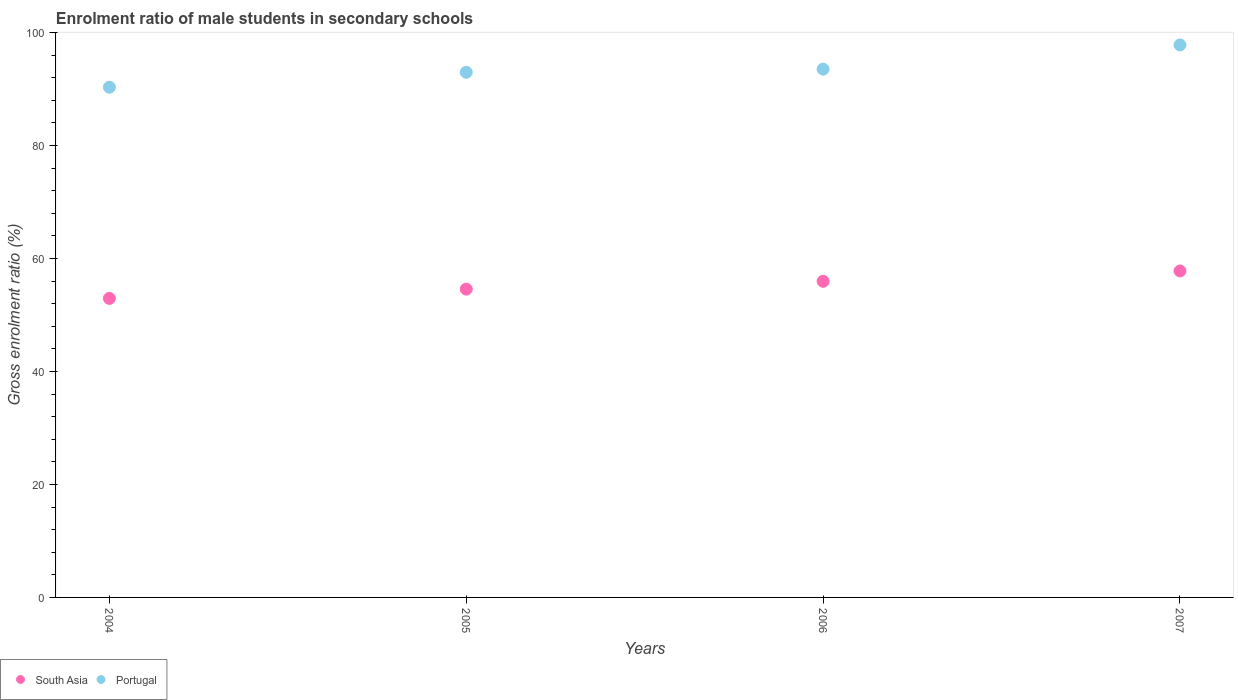Is the number of dotlines equal to the number of legend labels?
Your answer should be compact. Yes. What is the enrolment ratio of male students in secondary schools in South Asia in 2006?
Provide a succinct answer. 55.97. Across all years, what is the maximum enrolment ratio of male students in secondary schools in South Asia?
Give a very brief answer. 57.8. Across all years, what is the minimum enrolment ratio of male students in secondary schools in Portugal?
Offer a very short reply. 90.32. In which year was the enrolment ratio of male students in secondary schools in Portugal maximum?
Ensure brevity in your answer.  2007. In which year was the enrolment ratio of male students in secondary schools in Portugal minimum?
Provide a succinct answer. 2004. What is the total enrolment ratio of male students in secondary schools in Portugal in the graph?
Provide a succinct answer. 374.64. What is the difference between the enrolment ratio of male students in secondary schools in Portugal in 2005 and that in 2007?
Offer a terse response. -4.84. What is the difference between the enrolment ratio of male students in secondary schools in Portugal in 2006 and the enrolment ratio of male students in secondary schools in South Asia in 2004?
Ensure brevity in your answer.  40.59. What is the average enrolment ratio of male students in secondary schools in Portugal per year?
Ensure brevity in your answer.  93.66. In the year 2006, what is the difference between the enrolment ratio of male students in secondary schools in South Asia and enrolment ratio of male students in secondary schools in Portugal?
Keep it short and to the point. -37.55. In how many years, is the enrolment ratio of male students in secondary schools in Portugal greater than 4 %?
Ensure brevity in your answer.  4. What is the ratio of the enrolment ratio of male students in secondary schools in Portugal in 2005 to that in 2006?
Provide a short and direct response. 0.99. Is the enrolment ratio of male students in secondary schools in Portugal in 2005 less than that in 2007?
Your response must be concise. Yes. What is the difference between the highest and the second highest enrolment ratio of male students in secondary schools in South Asia?
Provide a short and direct response. 1.83. What is the difference between the highest and the lowest enrolment ratio of male students in secondary schools in Portugal?
Give a very brief answer. 7.49. In how many years, is the enrolment ratio of male students in secondary schools in Portugal greater than the average enrolment ratio of male students in secondary schools in Portugal taken over all years?
Keep it short and to the point. 1. Does the enrolment ratio of male students in secondary schools in South Asia monotonically increase over the years?
Provide a short and direct response. Yes. Is the enrolment ratio of male students in secondary schools in South Asia strictly less than the enrolment ratio of male students in secondary schools in Portugal over the years?
Offer a terse response. Yes. How many dotlines are there?
Offer a terse response. 2. What is the difference between two consecutive major ticks on the Y-axis?
Ensure brevity in your answer.  20. Are the values on the major ticks of Y-axis written in scientific E-notation?
Provide a short and direct response. No. Does the graph contain any zero values?
Provide a short and direct response. No. Where does the legend appear in the graph?
Your answer should be compact. Bottom left. How many legend labels are there?
Ensure brevity in your answer.  2. How are the legend labels stacked?
Your response must be concise. Horizontal. What is the title of the graph?
Provide a succinct answer. Enrolment ratio of male students in secondary schools. What is the label or title of the X-axis?
Your response must be concise. Years. What is the label or title of the Y-axis?
Give a very brief answer. Gross enrolment ratio (%). What is the Gross enrolment ratio (%) in South Asia in 2004?
Provide a short and direct response. 52.94. What is the Gross enrolment ratio (%) of Portugal in 2004?
Give a very brief answer. 90.32. What is the Gross enrolment ratio (%) in South Asia in 2005?
Your answer should be very brief. 54.58. What is the Gross enrolment ratio (%) in Portugal in 2005?
Your answer should be compact. 92.98. What is the Gross enrolment ratio (%) in South Asia in 2006?
Provide a succinct answer. 55.97. What is the Gross enrolment ratio (%) of Portugal in 2006?
Your answer should be very brief. 93.53. What is the Gross enrolment ratio (%) in South Asia in 2007?
Keep it short and to the point. 57.8. What is the Gross enrolment ratio (%) in Portugal in 2007?
Offer a terse response. 97.81. Across all years, what is the maximum Gross enrolment ratio (%) in South Asia?
Offer a very short reply. 57.8. Across all years, what is the maximum Gross enrolment ratio (%) of Portugal?
Provide a short and direct response. 97.81. Across all years, what is the minimum Gross enrolment ratio (%) in South Asia?
Your response must be concise. 52.94. Across all years, what is the minimum Gross enrolment ratio (%) in Portugal?
Provide a short and direct response. 90.32. What is the total Gross enrolment ratio (%) in South Asia in the graph?
Your answer should be very brief. 221.29. What is the total Gross enrolment ratio (%) in Portugal in the graph?
Offer a terse response. 374.64. What is the difference between the Gross enrolment ratio (%) in South Asia in 2004 and that in 2005?
Provide a short and direct response. -1.64. What is the difference between the Gross enrolment ratio (%) in Portugal in 2004 and that in 2005?
Offer a terse response. -2.65. What is the difference between the Gross enrolment ratio (%) of South Asia in 2004 and that in 2006?
Provide a succinct answer. -3.03. What is the difference between the Gross enrolment ratio (%) in Portugal in 2004 and that in 2006?
Ensure brevity in your answer.  -3.2. What is the difference between the Gross enrolment ratio (%) of South Asia in 2004 and that in 2007?
Your answer should be very brief. -4.86. What is the difference between the Gross enrolment ratio (%) in Portugal in 2004 and that in 2007?
Your answer should be compact. -7.49. What is the difference between the Gross enrolment ratio (%) of South Asia in 2005 and that in 2006?
Your answer should be very brief. -1.39. What is the difference between the Gross enrolment ratio (%) in Portugal in 2005 and that in 2006?
Offer a terse response. -0.55. What is the difference between the Gross enrolment ratio (%) in South Asia in 2005 and that in 2007?
Give a very brief answer. -3.22. What is the difference between the Gross enrolment ratio (%) in Portugal in 2005 and that in 2007?
Provide a short and direct response. -4.84. What is the difference between the Gross enrolment ratio (%) in South Asia in 2006 and that in 2007?
Your answer should be very brief. -1.83. What is the difference between the Gross enrolment ratio (%) in Portugal in 2006 and that in 2007?
Your answer should be very brief. -4.29. What is the difference between the Gross enrolment ratio (%) in South Asia in 2004 and the Gross enrolment ratio (%) in Portugal in 2005?
Give a very brief answer. -40.04. What is the difference between the Gross enrolment ratio (%) of South Asia in 2004 and the Gross enrolment ratio (%) of Portugal in 2006?
Provide a succinct answer. -40.59. What is the difference between the Gross enrolment ratio (%) of South Asia in 2004 and the Gross enrolment ratio (%) of Portugal in 2007?
Your response must be concise. -44.88. What is the difference between the Gross enrolment ratio (%) in South Asia in 2005 and the Gross enrolment ratio (%) in Portugal in 2006?
Your answer should be very brief. -38.95. What is the difference between the Gross enrolment ratio (%) in South Asia in 2005 and the Gross enrolment ratio (%) in Portugal in 2007?
Provide a succinct answer. -43.24. What is the difference between the Gross enrolment ratio (%) of South Asia in 2006 and the Gross enrolment ratio (%) of Portugal in 2007?
Offer a terse response. -41.84. What is the average Gross enrolment ratio (%) in South Asia per year?
Ensure brevity in your answer.  55.32. What is the average Gross enrolment ratio (%) of Portugal per year?
Provide a short and direct response. 93.66. In the year 2004, what is the difference between the Gross enrolment ratio (%) of South Asia and Gross enrolment ratio (%) of Portugal?
Your answer should be compact. -37.38. In the year 2005, what is the difference between the Gross enrolment ratio (%) of South Asia and Gross enrolment ratio (%) of Portugal?
Give a very brief answer. -38.4. In the year 2006, what is the difference between the Gross enrolment ratio (%) in South Asia and Gross enrolment ratio (%) in Portugal?
Give a very brief answer. -37.55. In the year 2007, what is the difference between the Gross enrolment ratio (%) of South Asia and Gross enrolment ratio (%) of Portugal?
Provide a short and direct response. -40.02. What is the ratio of the Gross enrolment ratio (%) in South Asia in 2004 to that in 2005?
Offer a very short reply. 0.97. What is the ratio of the Gross enrolment ratio (%) of Portugal in 2004 to that in 2005?
Offer a very short reply. 0.97. What is the ratio of the Gross enrolment ratio (%) of South Asia in 2004 to that in 2006?
Offer a terse response. 0.95. What is the ratio of the Gross enrolment ratio (%) in Portugal in 2004 to that in 2006?
Your answer should be compact. 0.97. What is the ratio of the Gross enrolment ratio (%) in South Asia in 2004 to that in 2007?
Provide a succinct answer. 0.92. What is the ratio of the Gross enrolment ratio (%) of Portugal in 2004 to that in 2007?
Offer a terse response. 0.92. What is the ratio of the Gross enrolment ratio (%) in South Asia in 2005 to that in 2006?
Make the answer very short. 0.98. What is the ratio of the Gross enrolment ratio (%) in South Asia in 2005 to that in 2007?
Your response must be concise. 0.94. What is the ratio of the Gross enrolment ratio (%) of Portugal in 2005 to that in 2007?
Your answer should be compact. 0.95. What is the ratio of the Gross enrolment ratio (%) in South Asia in 2006 to that in 2007?
Ensure brevity in your answer.  0.97. What is the ratio of the Gross enrolment ratio (%) in Portugal in 2006 to that in 2007?
Keep it short and to the point. 0.96. What is the difference between the highest and the second highest Gross enrolment ratio (%) of South Asia?
Make the answer very short. 1.83. What is the difference between the highest and the second highest Gross enrolment ratio (%) in Portugal?
Make the answer very short. 4.29. What is the difference between the highest and the lowest Gross enrolment ratio (%) in South Asia?
Your answer should be very brief. 4.86. What is the difference between the highest and the lowest Gross enrolment ratio (%) in Portugal?
Your answer should be compact. 7.49. 